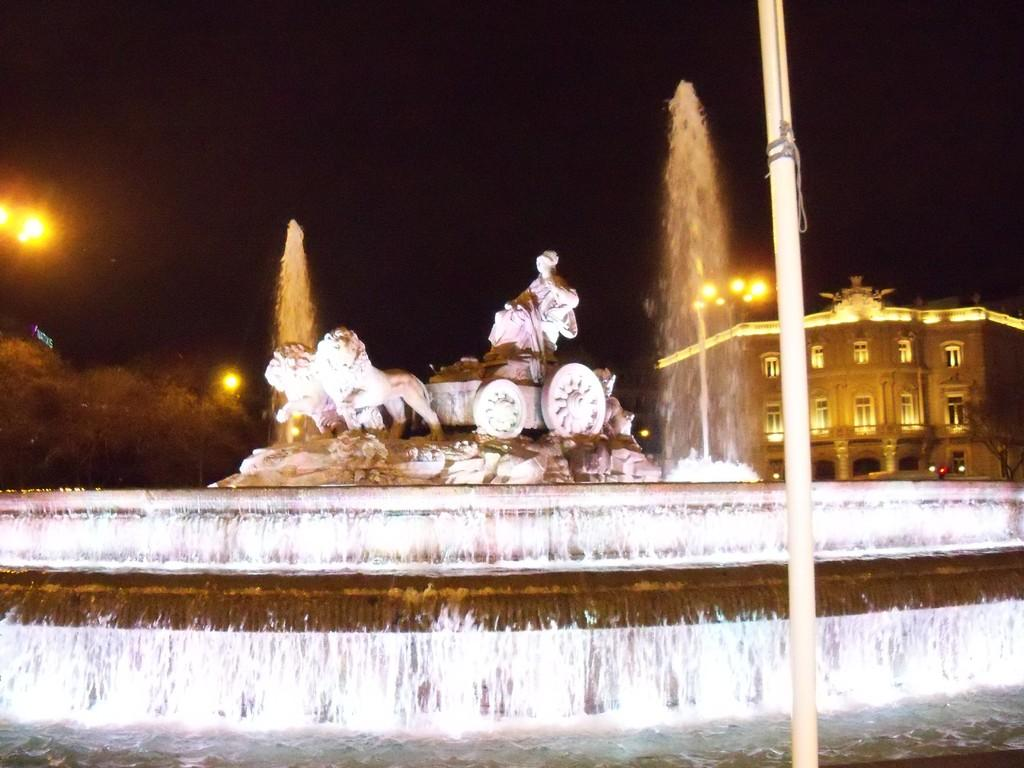What is located at the front of the image? There is a pole in the front of the image. What can be seen in the center of the image? There is a water fountain in the center of the image. What type of objects are present in the image besides the pole and water fountain? There are statues in the image. What can be seen in the background of the image? There are trees, poles, and a building in the background of the image. How does the crow interact with the water fountain in the image? There is no crow present in the image; it only features a pole, water fountain, statues, trees, poles, and a building. What type of addition is being performed by the statues in the image? The statues are not performing any addition in the image; they are stationary objects. 